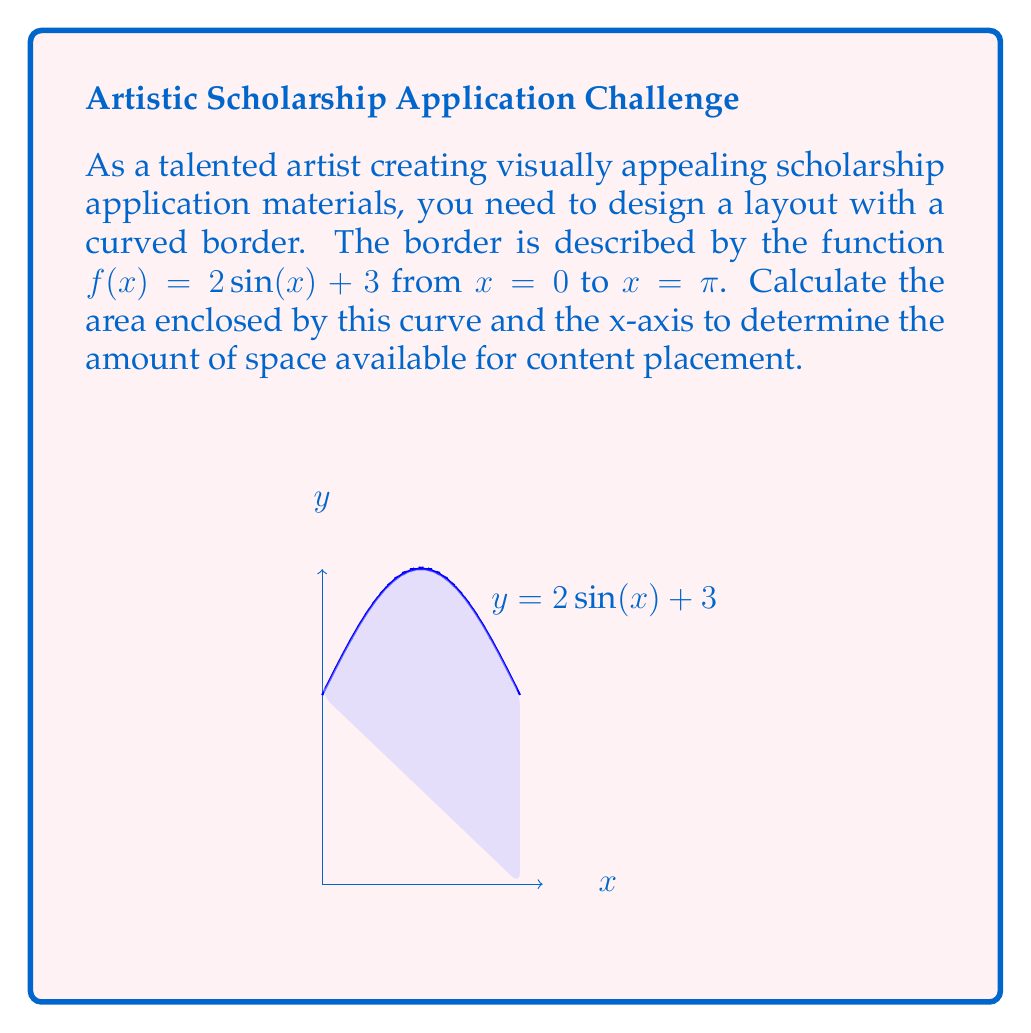Provide a solution to this math problem. To calculate the area under the curve, we need to integrate the function $f(x) = 2\sin(x) + 3$ from $x = 0$ to $x = \pi$. Let's follow these steps:

1) The integral to calculate the area is:

   $$A = \int_0^{\pi} (2\sin(x) + 3) dx$$

2) Let's split this into two integrals:

   $$A = \int_0^{\pi} 2\sin(x) dx + \int_0^{\pi} 3 dx$$

3) For the first integral, we know that $\int \sin(x) dx = -\cos(x) + C$. So:

   $$\int_0^{\pi} 2\sin(x) dx = -2\cos(x) \bigg|_0^{\pi} = -2(\cos(\pi) - \cos(0)) = -2(-1 - 1) = 4$$

4) For the second integral, it's a simple integral of a constant:

   $$\int_0^{\pi} 3 dx = 3x \bigg|_0^{\pi} = 3\pi - 0 = 3\pi$$

5) Adding the results from steps 3 and 4:

   $$A = 4 + 3\pi$$

Therefore, the area under the curve is $4 + 3\pi$ square units.
Answer: $4 + 3\pi$ square units 